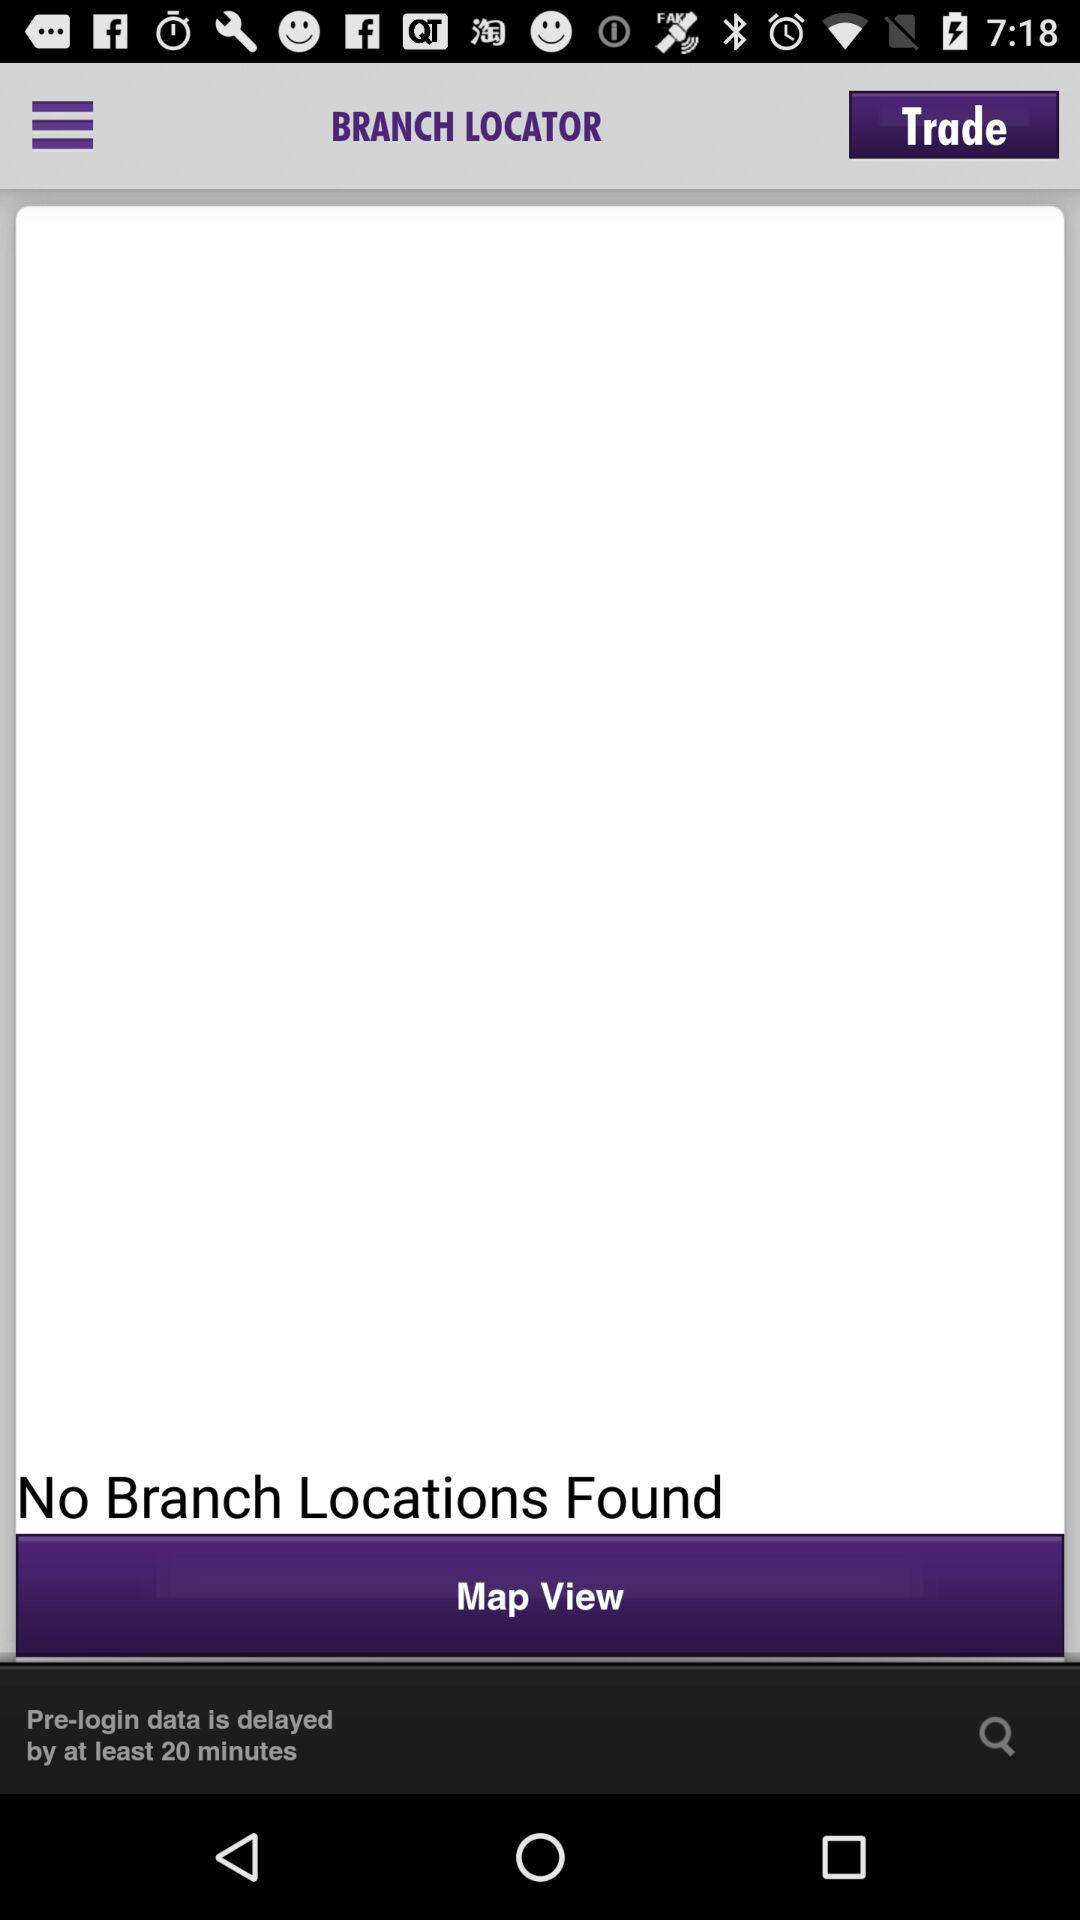Are there any branch locations found? There are no locations found. 